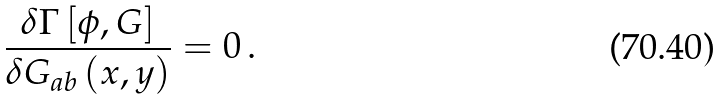<formula> <loc_0><loc_0><loc_500><loc_500>\frac { \delta \Gamma \left [ \phi , G \right ] } { \delta G _ { a b } \left ( x , y \right ) } = 0 \, .</formula> 